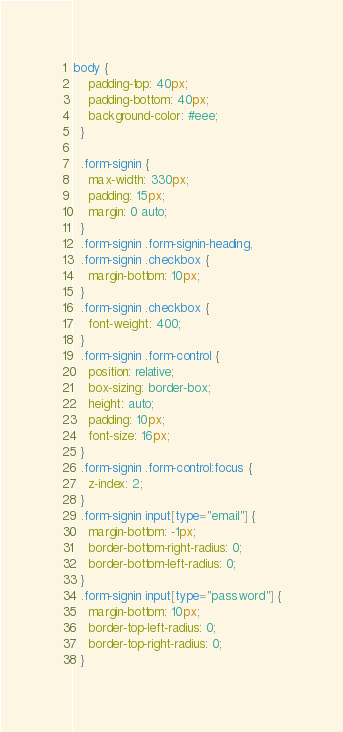Convert code to text. <code><loc_0><loc_0><loc_500><loc_500><_CSS_>body {
    padding-top: 40px;
    padding-bottom: 40px;
    background-color: #eee;
  }
  
  .form-signin {
    max-width: 330px;
    padding: 15px;
    margin: 0 auto;
  }
  .form-signin .form-signin-heading,
  .form-signin .checkbox {
    margin-bottom: 10px;
  }
  .form-signin .checkbox {
    font-weight: 400;
  }
  .form-signin .form-control {
    position: relative;
    box-sizing: border-box;
    height: auto;
    padding: 10px;
    font-size: 16px;
  }
  .form-signin .form-control:focus {
    z-index: 2;
  }
  .form-signin input[type="email"] {
    margin-bottom: -1px;
    border-bottom-right-radius: 0;
    border-bottom-left-radius: 0;
  }
  .form-signin input[type="password"] {
    margin-bottom: 10px;
    border-top-left-radius: 0;
    border-top-right-radius: 0;
  }</code> 